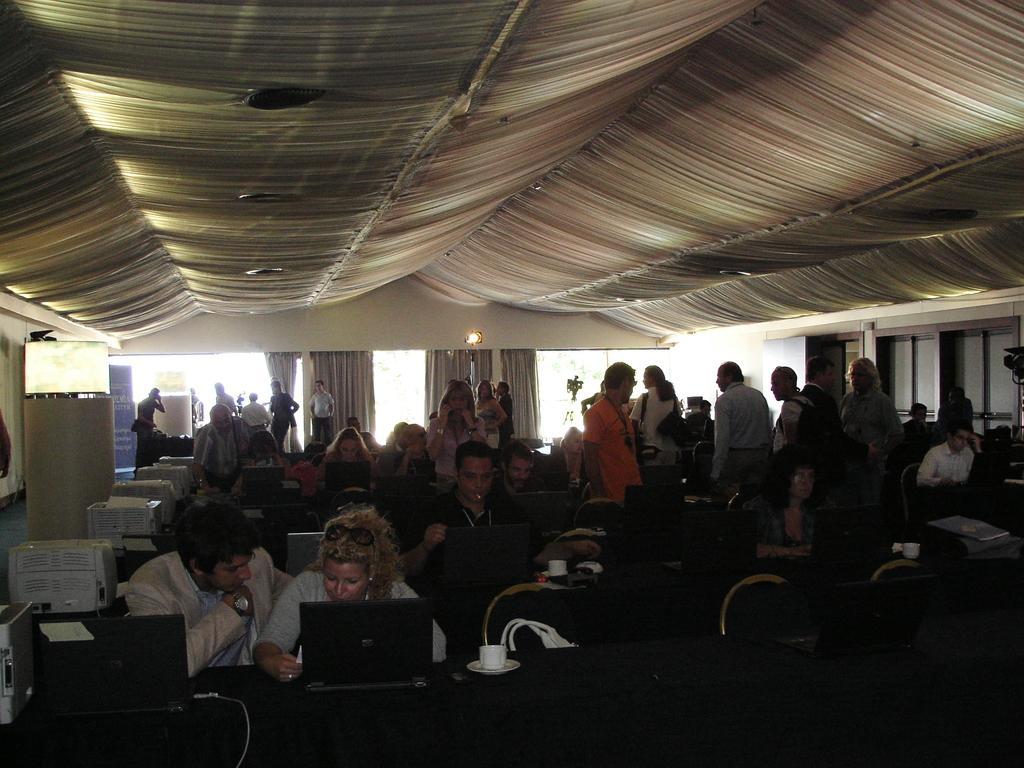Can you describe this image briefly? In this image there are a few people seated in chairs are working on the laptops in front of them on the table, on the table there, there are laptops, coffee cups and fax machines, behind them there are a few people standing, in the background if the image there are curtains. 